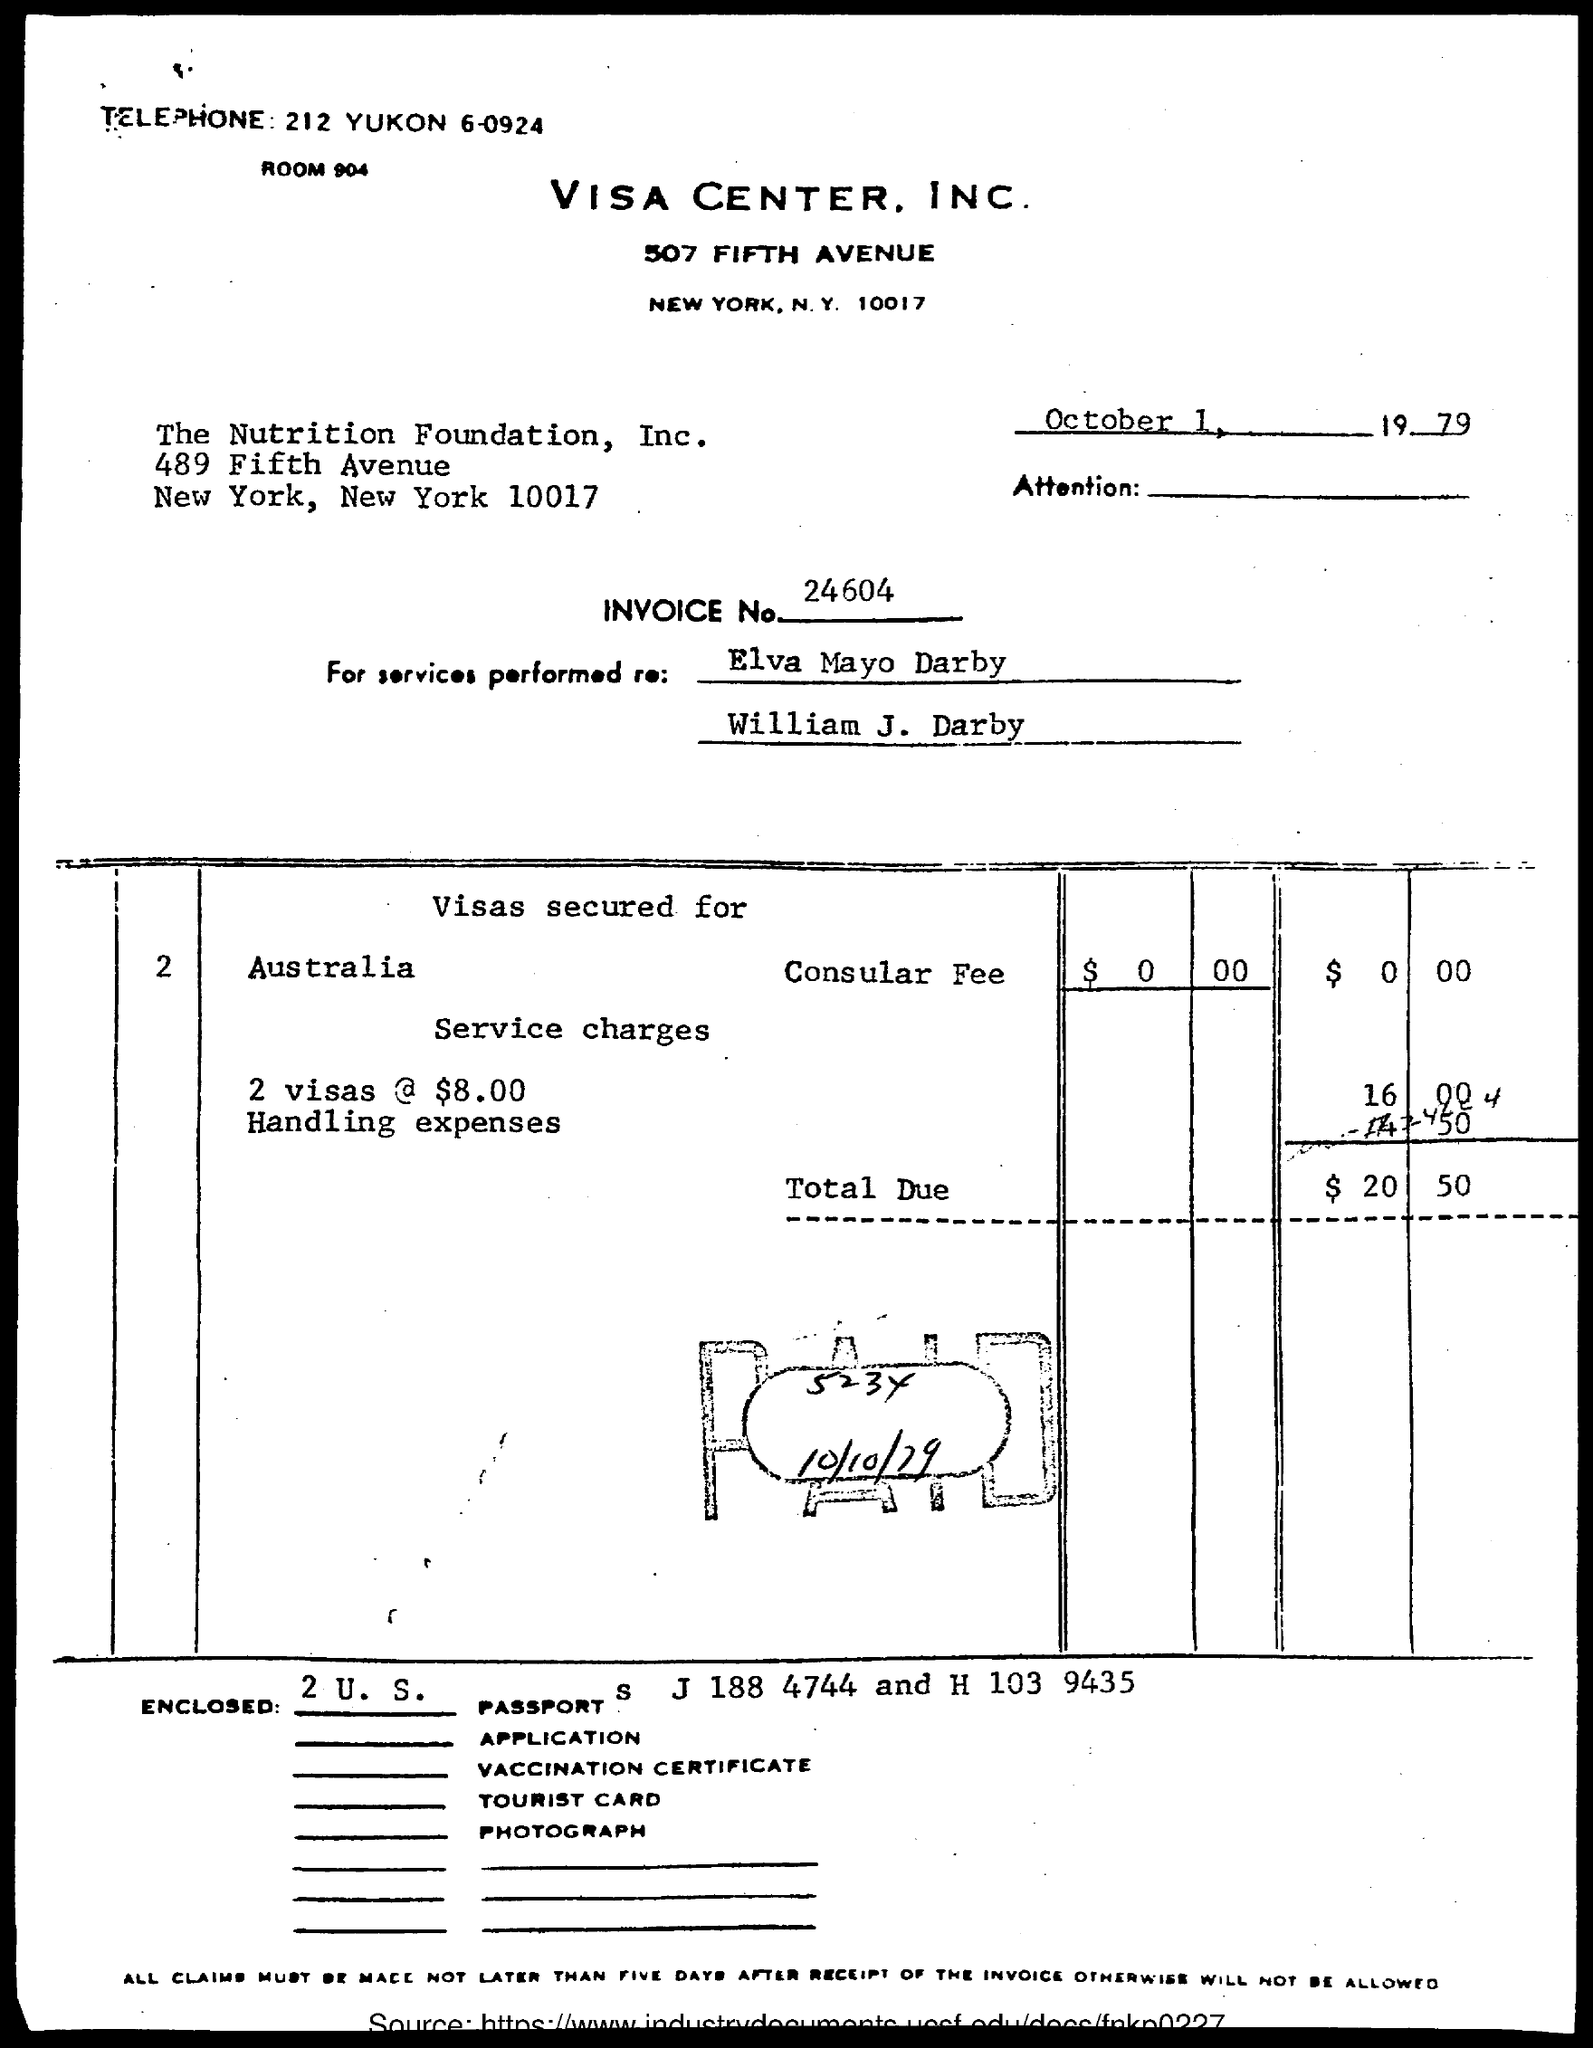Draw attention to some important aspects in this diagram. The place where visas are secured is Australia. The date and year mentioned in the document are October 1, 1979. The total due is $20.50. The Visa Center, Inc. room number is 904. Visa Center, Inc. can be contacted by phone at 212 YUKON 6-0924. 